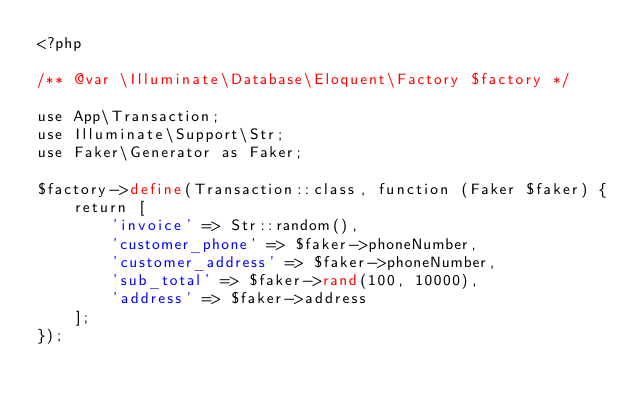Convert code to text. <code><loc_0><loc_0><loc_500><loc_500><_PHP_><?php

/** @var \Illuminate\Database\Eloquent\Factory $factory */

use App\Transaction;
use Illuminate\Support\Str;
use Faker\Generator as Faker;

$factory->define(Transaction::class, function (Faker $faker) {
    return [
        'invoice' => Str::random(),
        'customer_phone' => $faker->phoneNumber,
        'customer_address' => $faker->phoneNumber,
        'sub_total' => $faker->rand(100, 10000),
        'address' => $faker->address
    ];
});
</code> 